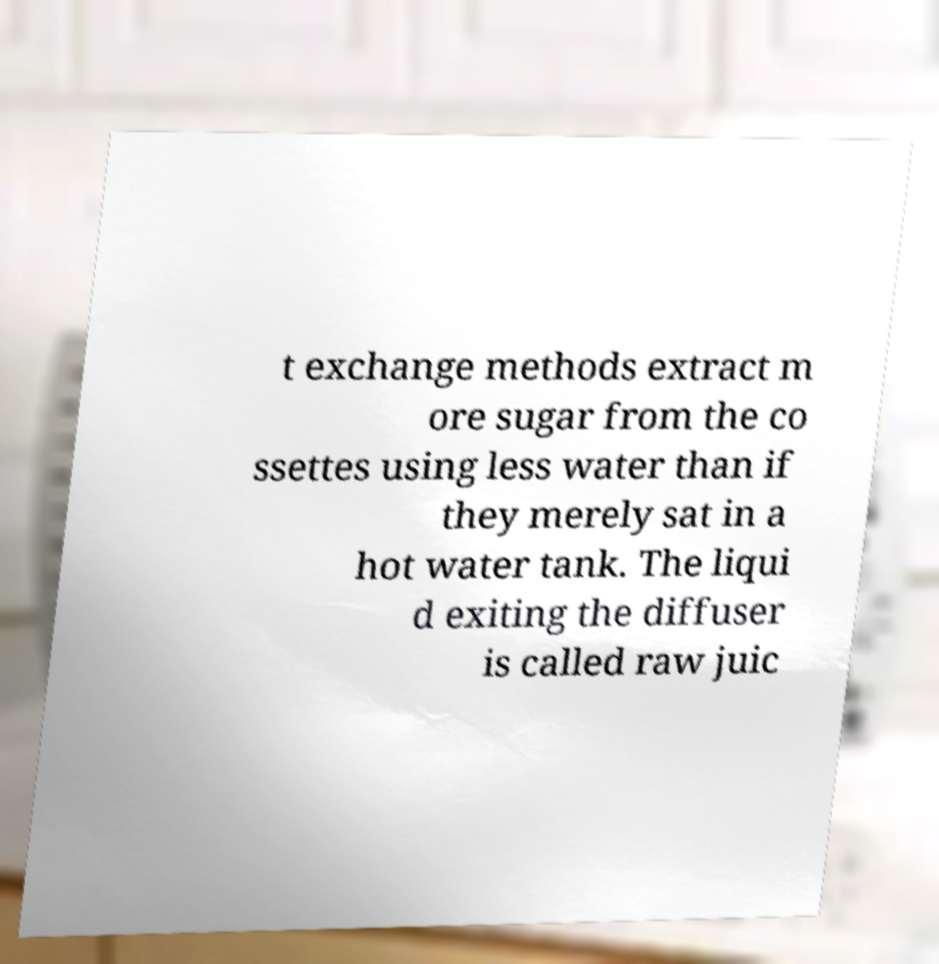For documentation purposes, I need the text within this image transcribed. Could you provide that? t exchange methods extract m ore sugar from the co ssettes using less water than if they merely sat in a hot water tank. The liqui d exiting the diffuser is called raw juic 